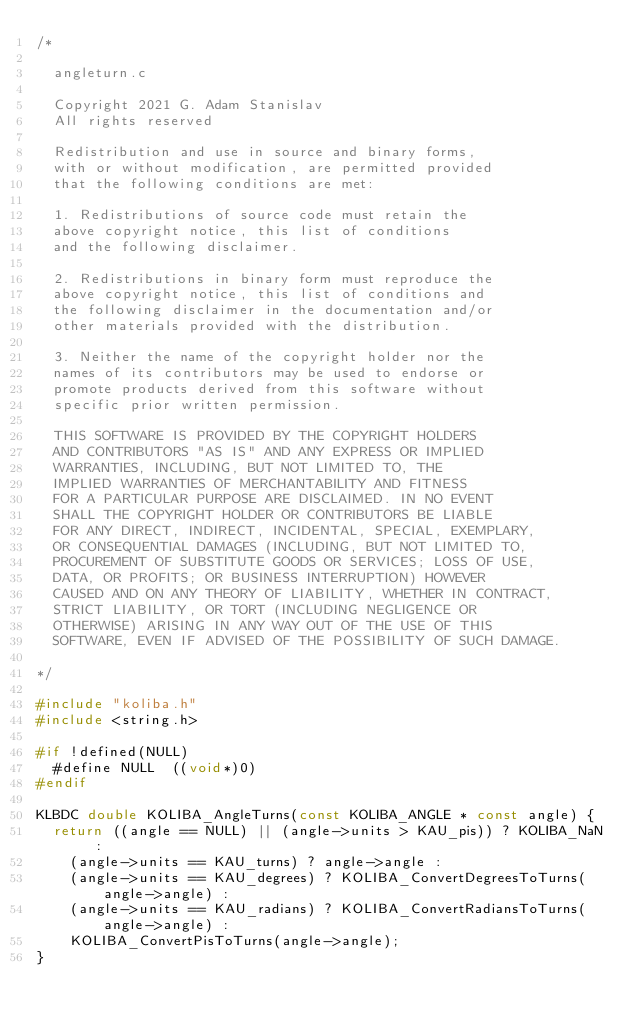<code> <loc_0><loc_0><loc_500><loc_500><_C_>/*

	angleturn.c

	Copyright 2021 G. Adam Stanislav
	All rights reserved

	Redistribution and use in source and binary forms,
	with or without modification, are permitted provided
	that the following conditions are met:

	1. Redistributions of source code must retain the
	above copyright notice, this list of conditions
	and the following disclaimer.

	2. Redistributions in binary form must reproduce the
	above copyright notice, this list of conditions and
	the following disclaimer in the documentation and/or
	other materials provided with the distribution.

	3. Neither the name of the copyright holder nor the
	names of its contributors may be used to endorse or
	promote products derived from this software without
	specific prior written permission.

	THIS SOFTWARE IS PROVIDED BY THE COPYRIGHT HOLDERS
	AND CONTRIBUTORS "AS IS" AND ANY EXPRESS OR IMPLIED
	WARRANTIES, INCLUDING, BUT NOT LIMITED TO, THE
	IMPLIED WARRANTIES OF MERCHANTABILITY AND FITNESS
	FOR A PARTICULAR PURPOSE ARE DISCLAIMED. IN NO EVENT
	SHALL THE COPYRIGHT HOLDER OR CONTRIBUTORS BE LIABLE
	FOR ANY DIRECT, INDIRECT, INCIDENTAL, SPECIAL, EXEMPLARY,
	OR CONSEQUENTIAL DAMAGES (INCLUDING, BUT NOT LIMITED TO,
	PROCUREMENT OF SUBSTITUTE GOODS OR SERVICES; LOSS OF USE,
	DATA, OR PROFITS; OR BUSINESS INTERRUPTION) HOWEVER
	CAUSED AND ON ANY THEORY OF LIABILITY, WHETHER IN CONTRACT,
	STRICT LIABILITY, OR TORT (INCLUDING NEGLIGENCE OR
	OTHERWISE) ARISING IN ANY WAY OUT OF THE USE OF THIS
	SOFTWARE, EVEN IF ADVISED OF THE POSSIBILITY OF SUCH DAMAGE.

*/

#include "koliba.h"
#include <string.h>

#if !defined(NULL)
	#define	NULL	((void*)0)
#endif

KLBDC double KOLIBA_AngleTurns(const KOLIBA_ANGLE * const angle) {
	return ((angle == NULL) || (angle->units > KAU_pis)) ? KOLIBA_NaN :
		(angle->units == KAU_turns) ? angle->angle :
		(angle->units == KAU_degrees) ? KOLIBA_ConvertDegreesToTurns(angle->angle) :
		(angle->units == KAU_radians) ? KOLIBA_ConvertRadiansToTurns(angle->angle) :
		KOLIBA_ConvertPisToTurns(angle->angle);
}
</code> 